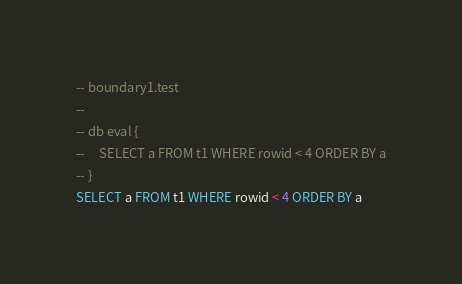Convert code to text. <code><loc_0><loc_0><loc_500><loc_500><_SQL_>-- boundary1.test
-- 
-- db eval {
--     SELECT a FROM t1 WHERE rowid < 4 ORDER BY a
-- }
SELECT a FROM t1 WHERE rowid < 4 ORDER BY a</code> 